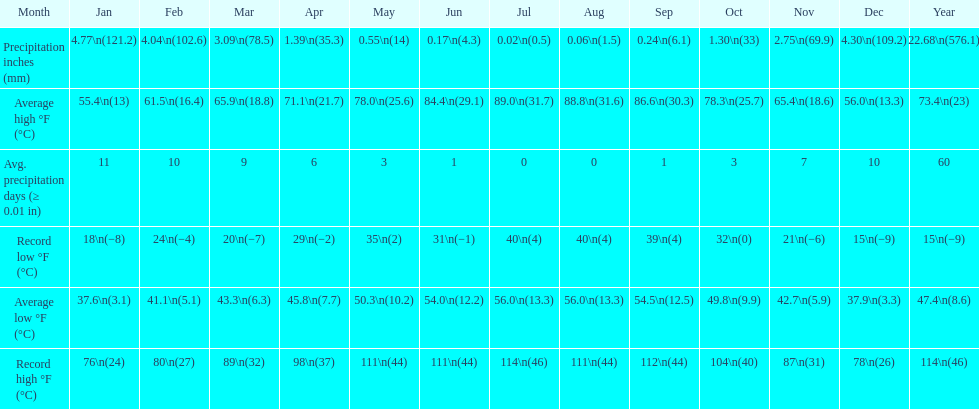In how many months is the record low beneath 25 degrees? 6. 